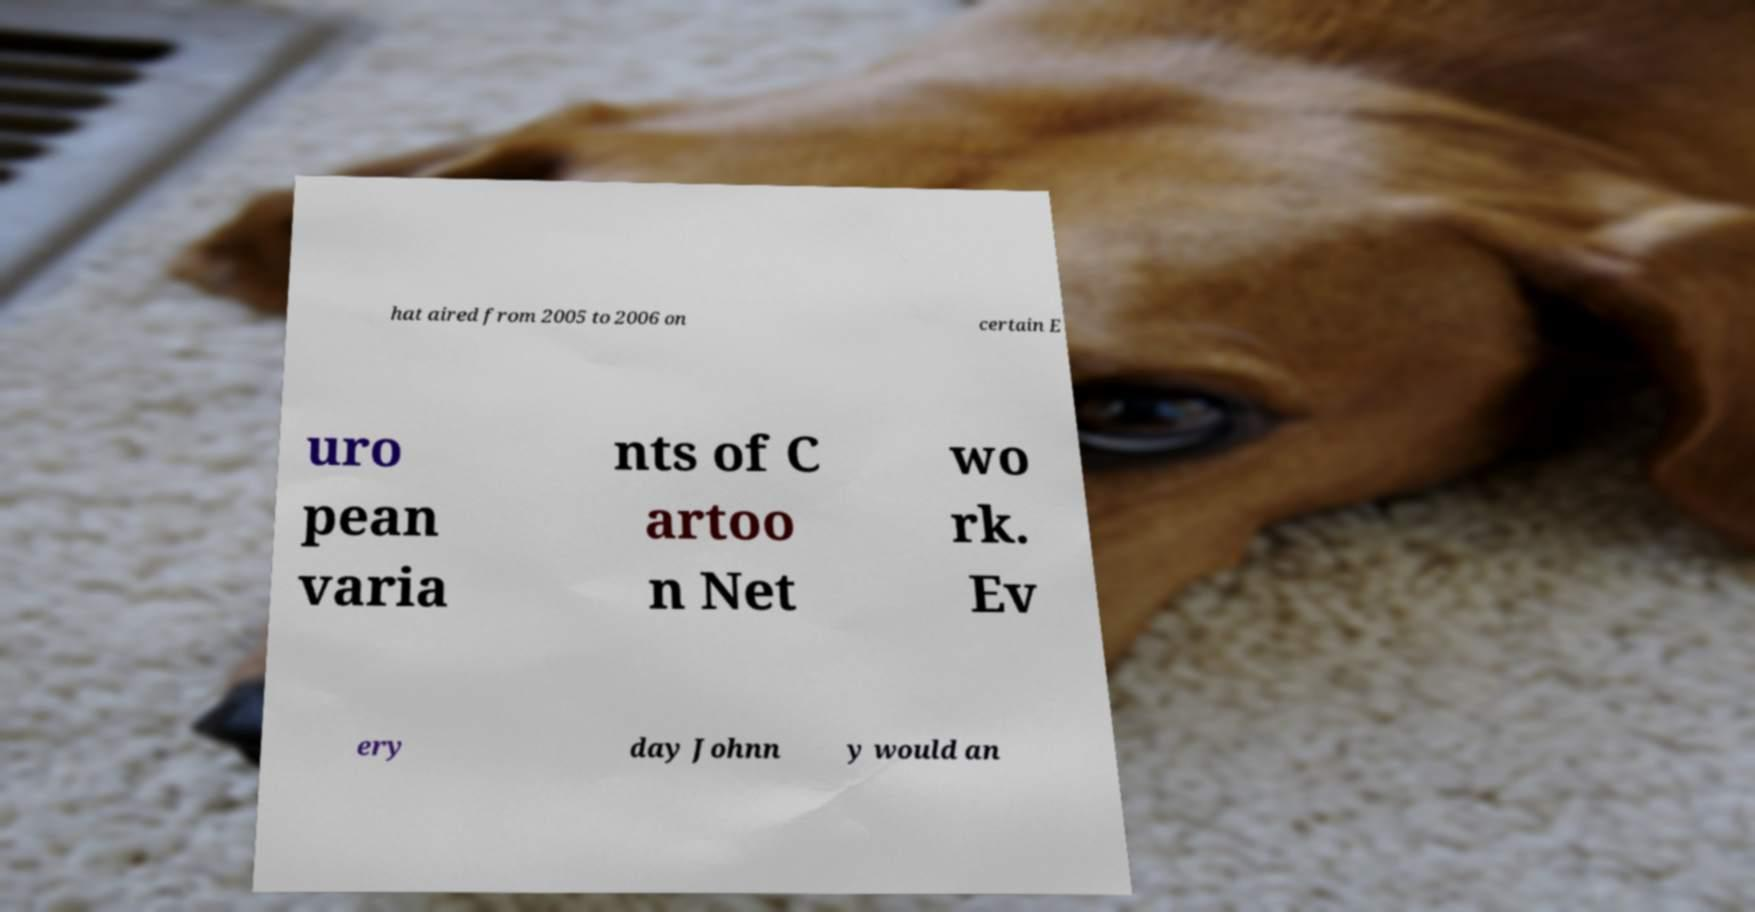Can you read and provide the text displayed in the image?This photo seems to have some interesting text. Can you extract and type it out for me? hat aired from 2005 to 2006 on certain E uro pean varia nts of C artoo n Net wo rk. Ev ery day Johnn y would an 